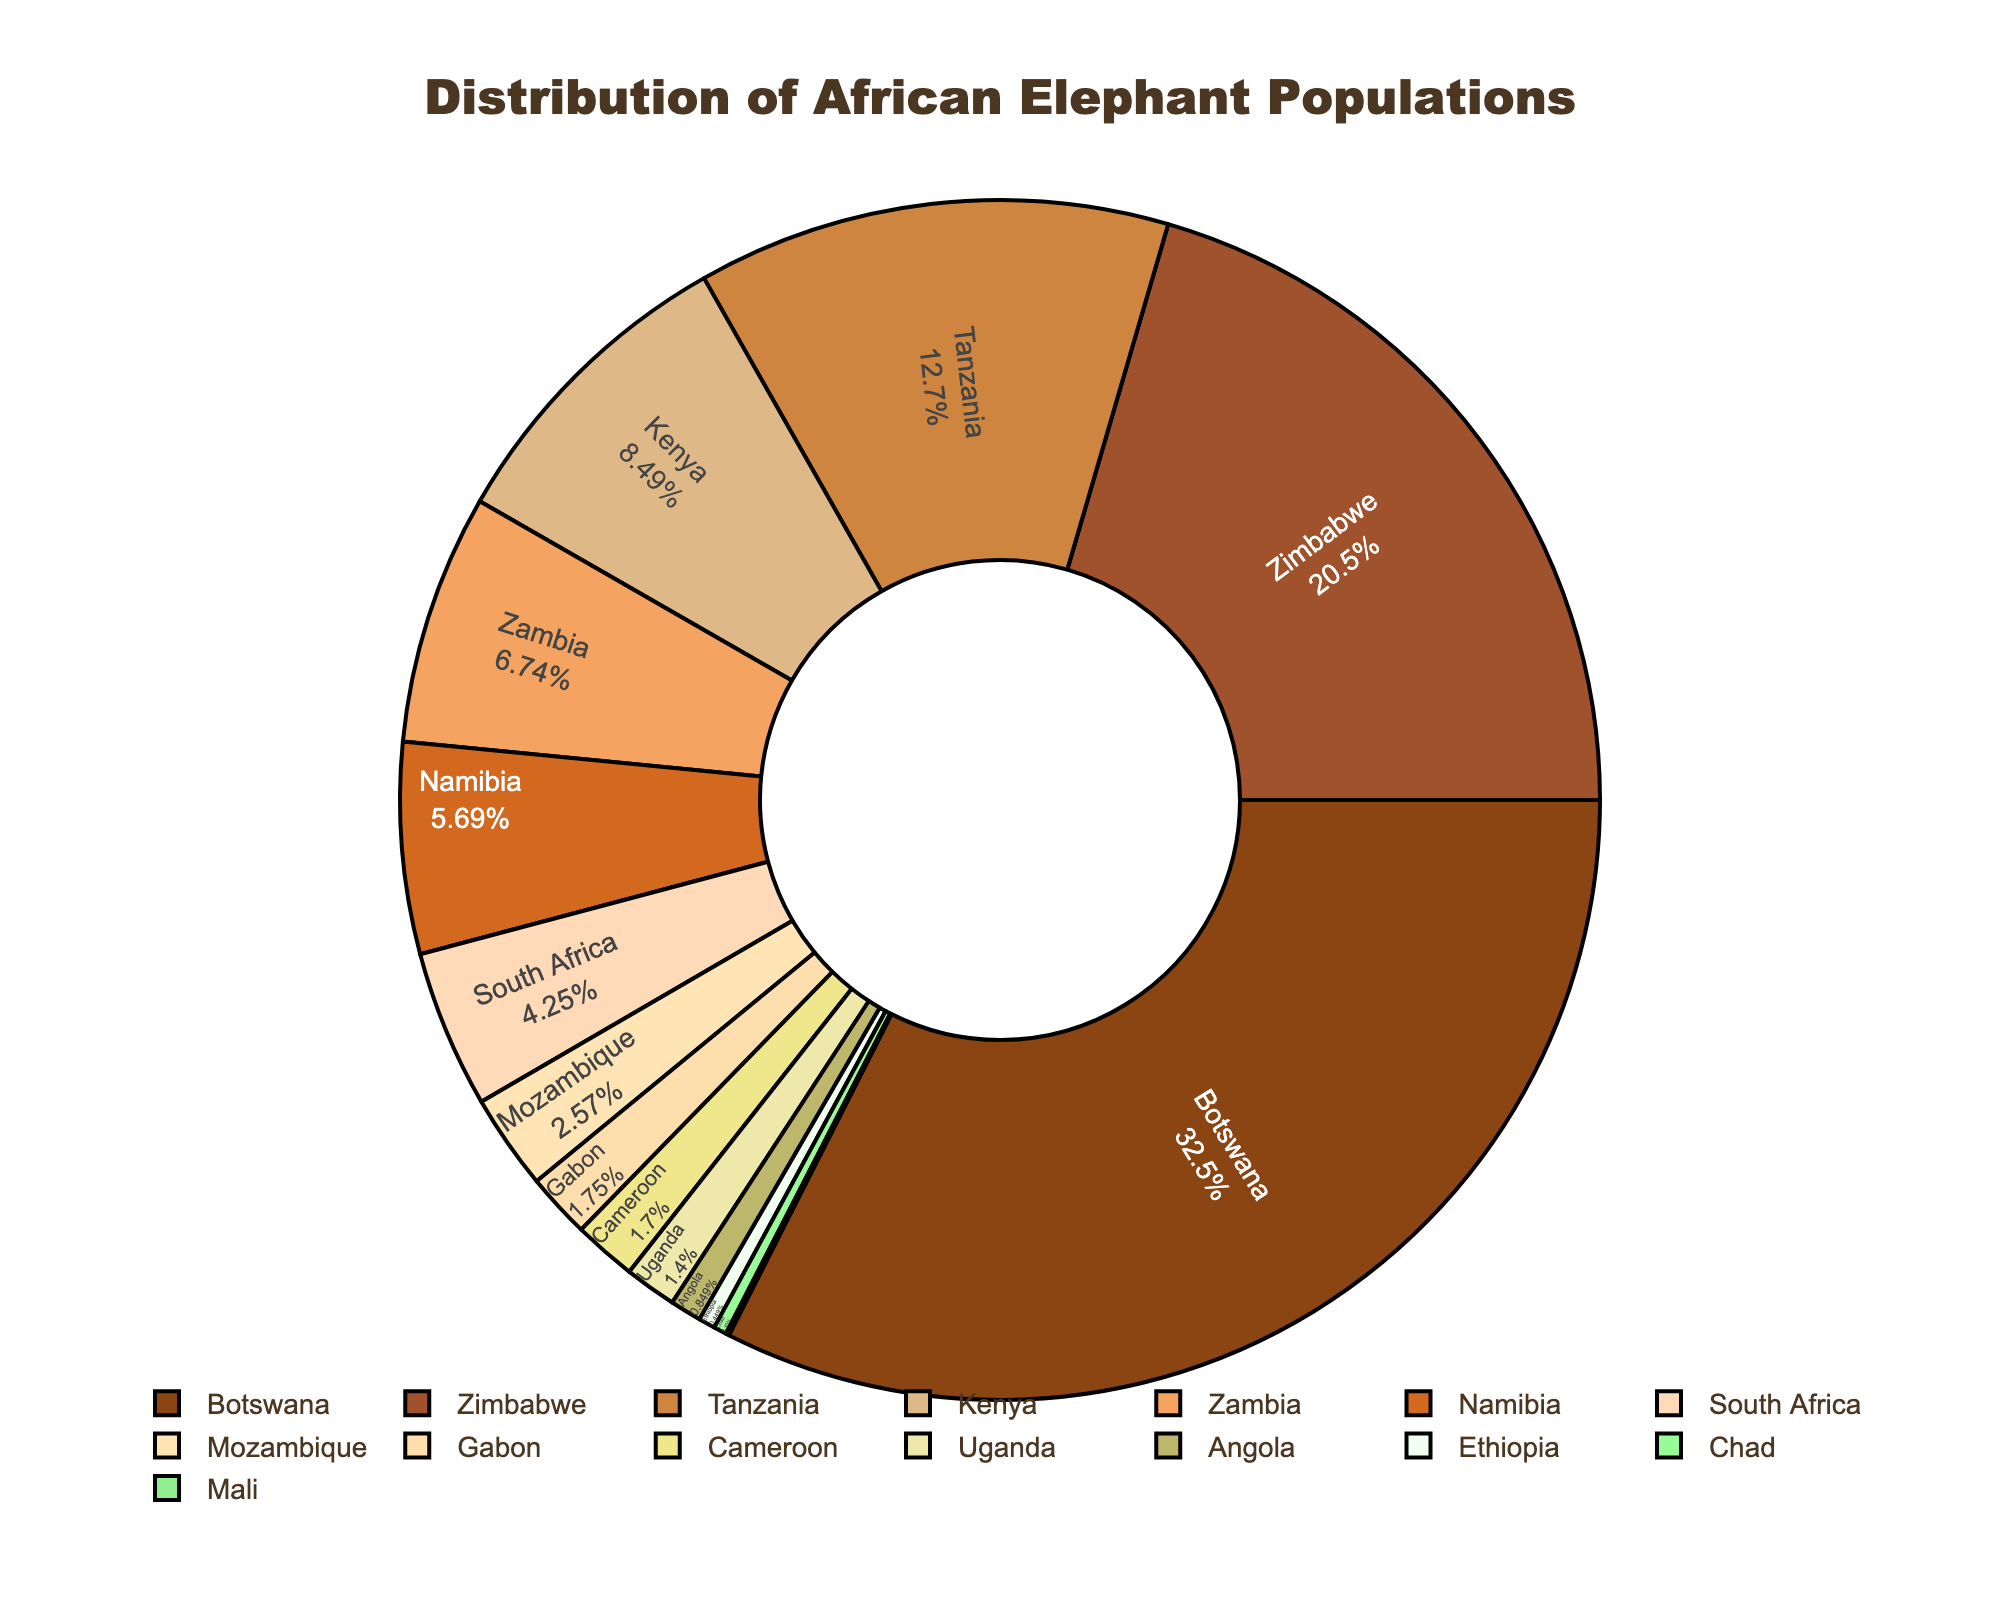Which country has the highest population of African elephants? By looking at the size of the slices, Botswana has the largest slice representing the largest population.
Answer: Botswana What percentage of the total African elephant population does Tanzania have? By referring to the label inside the slice for Tanzania, it shows the percentage contribution.
Answer: Refer to figure for exact % Which two countries combined have a population of roughly 100,000 elephants? Summing the populations of Zimbabwe and Tanzania equals 82,000 + 51,000 = 133,000, which is a bit over but can be adjusted by choosing isolating Zimbabwe (82,000). For a closer sum, consider Zambia and Namibia.
Answer: Zimbabwe and Tanzania How does the elephant population in Mozambique compare to that of Namibia? Comparing the slices visually, Mozambique's slice is smaller than Namibia's slice.
Answer: Mozambique has a smaller population What is the combined total population of elephants for the three countries with the lowest populations? Summing up the three smallest populations: Mali (350), Chad (1400), Ethiopia (1800), the total is 350 + 1400 + 1800 = 3550.
Answer: 3550 Which country has a slightly higher population of elephants, Gabon or Cameroon? By comparing the slices, Gabon's slice is slightly larger than Cameroon's.
Answer: Gabon What is the average population of elephants in Zambia, Uganda, and Angola? Summing the populations of Zambia (27000), Uganda (5600), and Angola (3400) results in 36000, and dividing by 3 gives the average: 36000/3 = 12000.
Answer: 12000 Which countries have populations of African elephants greater than 20,000? By observing the distribution and numeric labels on the figure, countries like Botswana, Zimbabwe, Tanzania, Kenya, and Namibia have populations over 20,000.
Answer: Botswana, Zimbabwe, Tanzania, Kenya, Namibia How much larger is the elephant population in Botswana compared to that in Ethiopia? By subtracting Ethiopia's population from Botswana's population: 130000 - 1800 = 128200.
Answer: 128200 